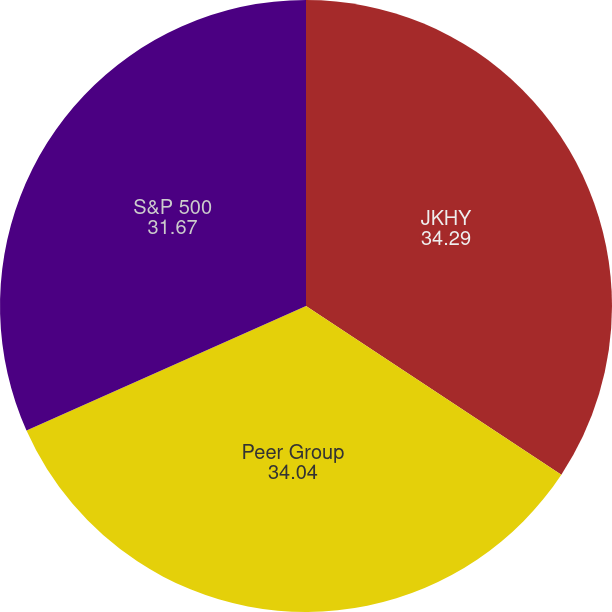<chart> <loc_0><loc_0><loc_500><loc_500><pie_chart><fcel>JKHY<fcel>Peer Group<fcel>S&P 500<nl><fcel>34.29%<fcel>34.04%<fcel>31.67%<nl></chart> 